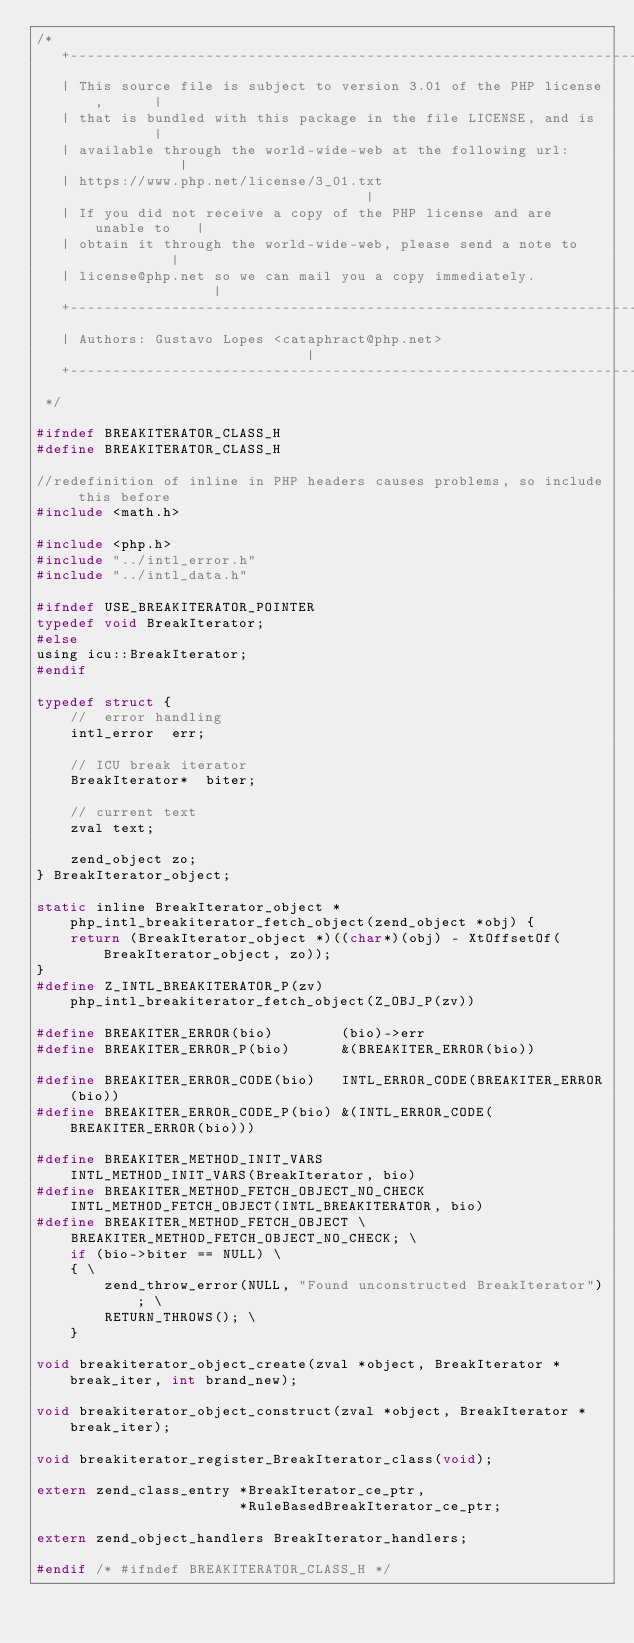Convert code to text. <code><loc_0><loc_0><loc_500><loc_500><_C_>/*
   +----------------------------------------------------------------------+
   | This source file is subject to version 3.01 of the PHP license,      |
   | that is bundled with this package in the file LICENSE, and is        |
   | available through the world-wide-web at the following url:           |
   | https://www.php.net/license/3_01.txt                                 |
   | If you did not receive a copy of the PHP license and are unable to   |
   | obtain it through the world-wide-web, please send a note to          |
   | license@php.net so we can mail you a copy immediately.               |
   +----------------------------------------------------------------------+
   | Authors: Gustavo Lopes <cataphract@php.net>                          |
   +----------------------------------------------------------------------+
 */

#ifndef BREAKITERATOR_CLASS_H
#define BREAKITERATOR_CLASS_H

//redefinition of inline in PHP headers causes problems, so include this before
#include <math.h>

#include <php.h>
#include "../intl_error.h"
#include "../intl_data.h"

#ifndef USE_BREAKITERATOR_POINTER
typedef void BreakIterator;
#else
using icu::BreakIterator;
#endif

typedef struct {
	// 	error handling
	intl_error  err;

	// ICU break iterator
	BreakIterator*	biter;

	// current text
	zval text;

	zend_object	zo;
} BreakIterator_object;

static inline BreakIterator_object *php_intl_breakiterator_fetch_object(zend_object *obj) {
	return (BreakIterator_object *)((char*)(obj) - XtOffsetOf(BreakIterator_object, zo));
}
#define Z_INTL_BREAKITERATOR_P(zv) php_intl_breakiterator_fetch_object(Z_OBJ_P(zv))

#define BREAKITER_ERROR(bio)		(bio)->err
#define BREAKITER_ERROR_P(bio)		&(BREAKITER_ERROR(bio))

#define BREAKITER_ERROR_CODE(bio)	INTL_ERROR_CODE(BREAKITER_ERROR(bio))
#define BREAKITER_ERROR_CODE_P(bio)	&(INTL_ERROR_CODE(BREAKITER_ERROR(bio)))

#define BREAKITER_METHOD_INIT_VARS		        INTL_METHOD_INIT_VARS(BreakIterator, bio)
#define BREAKITER_METHOD_FETCH_OBJECT_NO_CHECK	INTL_METHOD_FETCH_OBJECT(INTL_BREAKITERATOR, bio)
#define BREAKITER_METHOD_FETCH_OBJECT \
	BREAKITER_METHOD_FETCH_OBJECT_NO_CHECK; \
	if (bio->biter == NULL) \
	{ \
		zend_throw_error(NULL, "Found unconstructed BreakIterator"); \
		RETURN_THROWS(); \
	}

void breakiterator_object_create(zval *object, BreakIterator *break_iter, int brand_new);

void breakiterator_object_construct(zval *object, BreakIterator *break_iter);

void breakiterator_register_BreakIterator_class(void);

extern zend_class_entry *BreakIterator_ce_ptr,
						*RuleBasedBreakIterator_ce_ptr;

extern zend_object_handlers BreakIterator_handlers;

#endif /* #ifndef BREAKITERATOR_CLASS_H */
</code> 